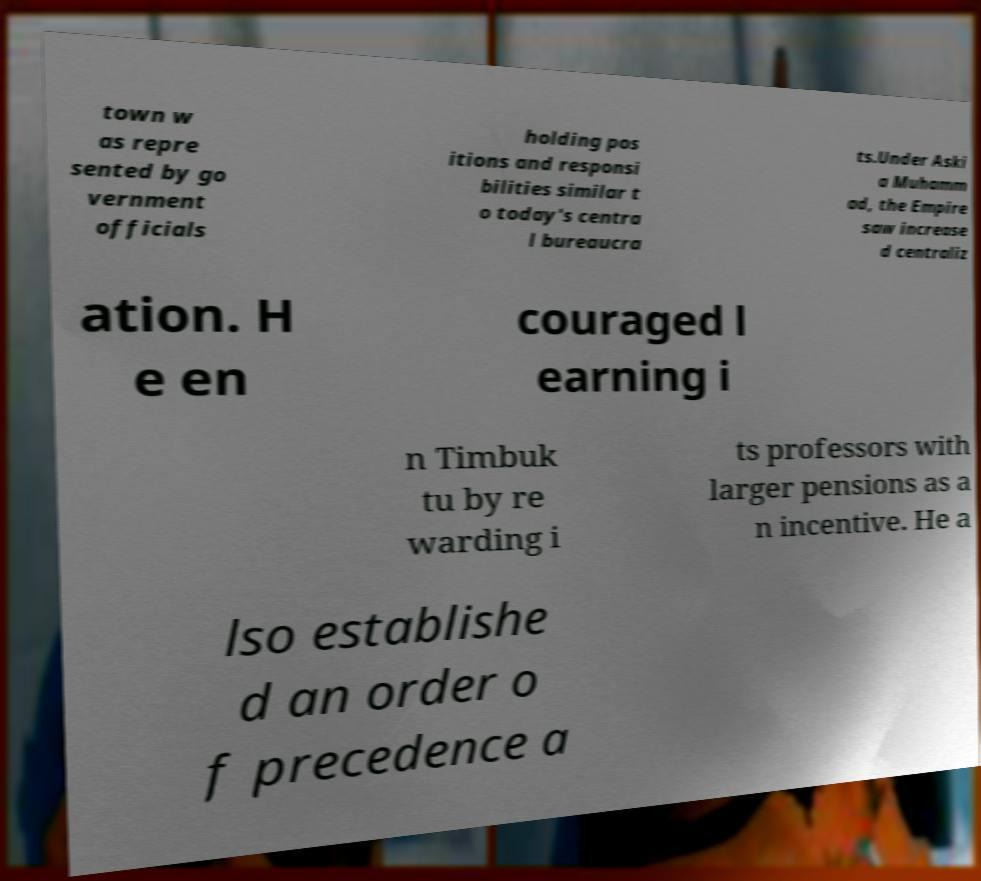There's text embedded in this image that I need extracted. Can you transcribe it verbatim? town w as repre sented by go vernment officials holding pos itions and responsi bilities similar t o today's centra l bureaucra ts.Under Aski a Muhamm ad, the Empire saw increase d centraliz ation. H e en couraged l earning i n Timbuk tu by re warding i ts professors with larger pensions as a n incentive. He a lso establishe d an order o f precedence a 